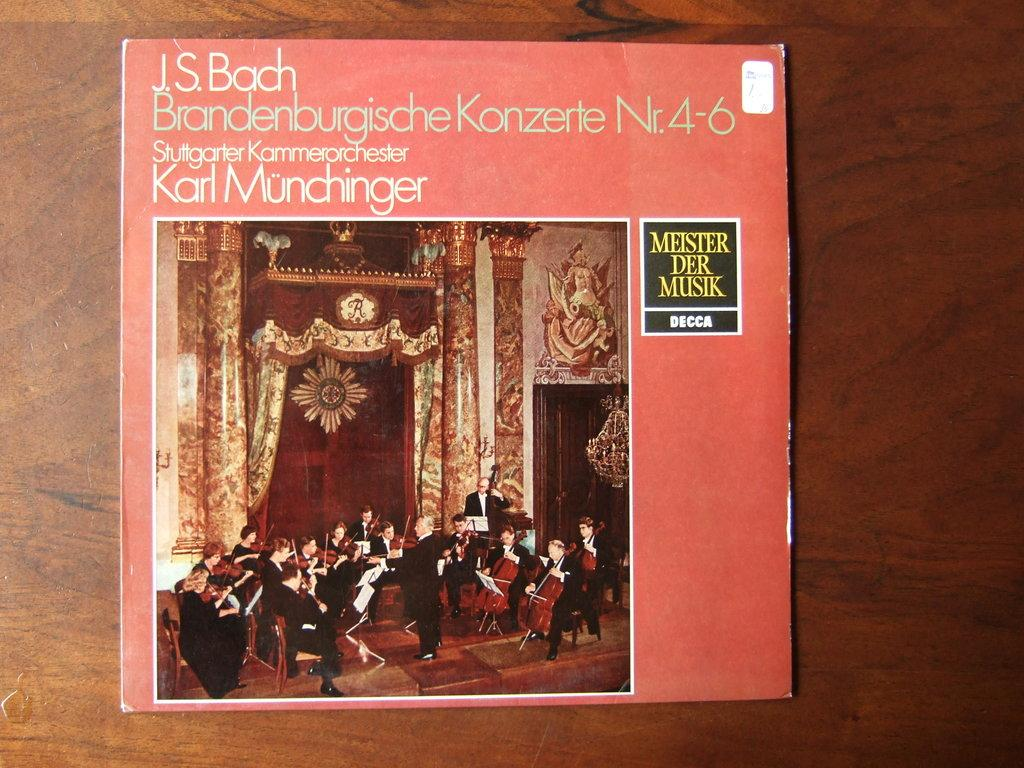Provide a one-sentence caption for the provided image. J.S. Bach Brandenburgische Konzerte Nr. 4-6 stuttgarter Kammerorchester Karl Munchinger album. 